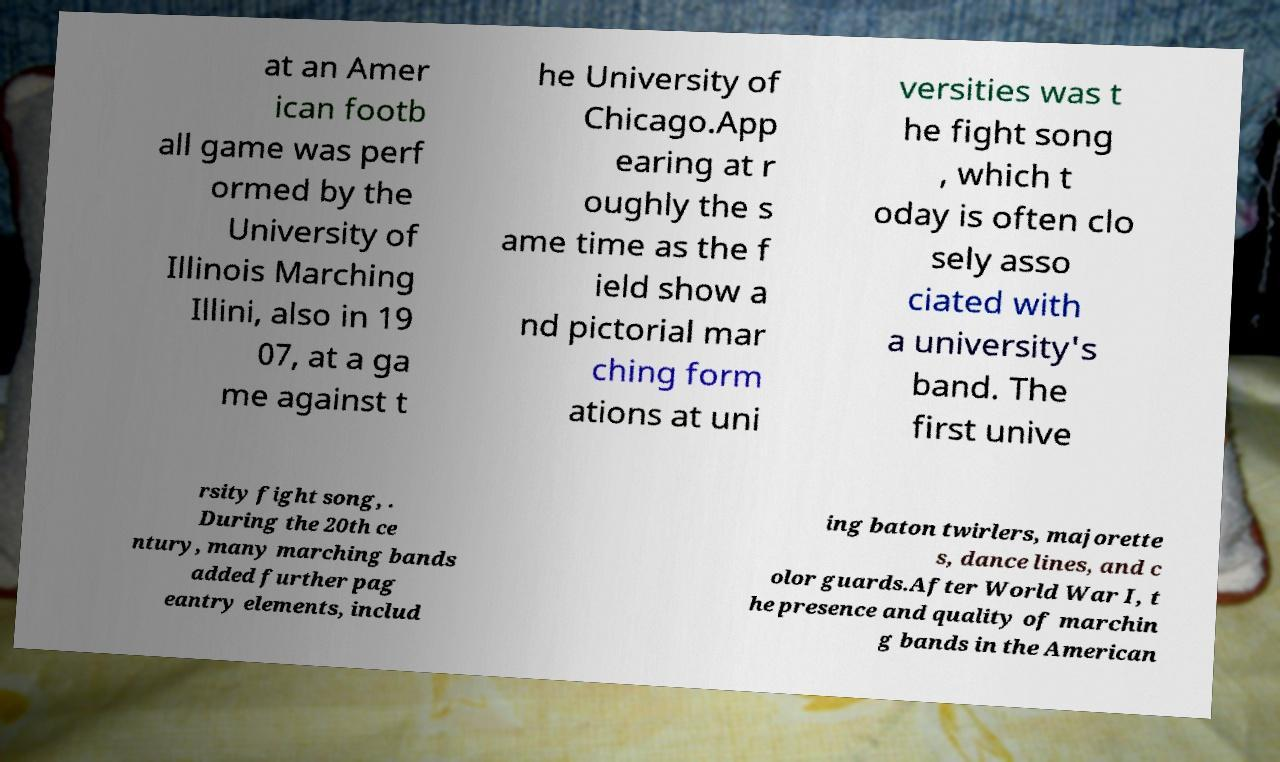Can you accurately transcribe the text from the provided image for me? at an Amer ican footb all game was perf ormed by the University of Illinois Marching Illini, also in 19 07, at a ga me against t he University of Chicago.App earing at r oughly the s ame time as the f ield show a nd pictorial mar ching form ations at uni versities was t he fight song , which t oday is often clo sely asso ciated with a university's band. The first unive rsity fight song, . During the 20th ce ntury, many marching bands added further pag eantry elements, includ ing baton twirlers, majorette s, dance lines, and c olor guards.After World War I, t he presence and quality of marchin g bands in the American 